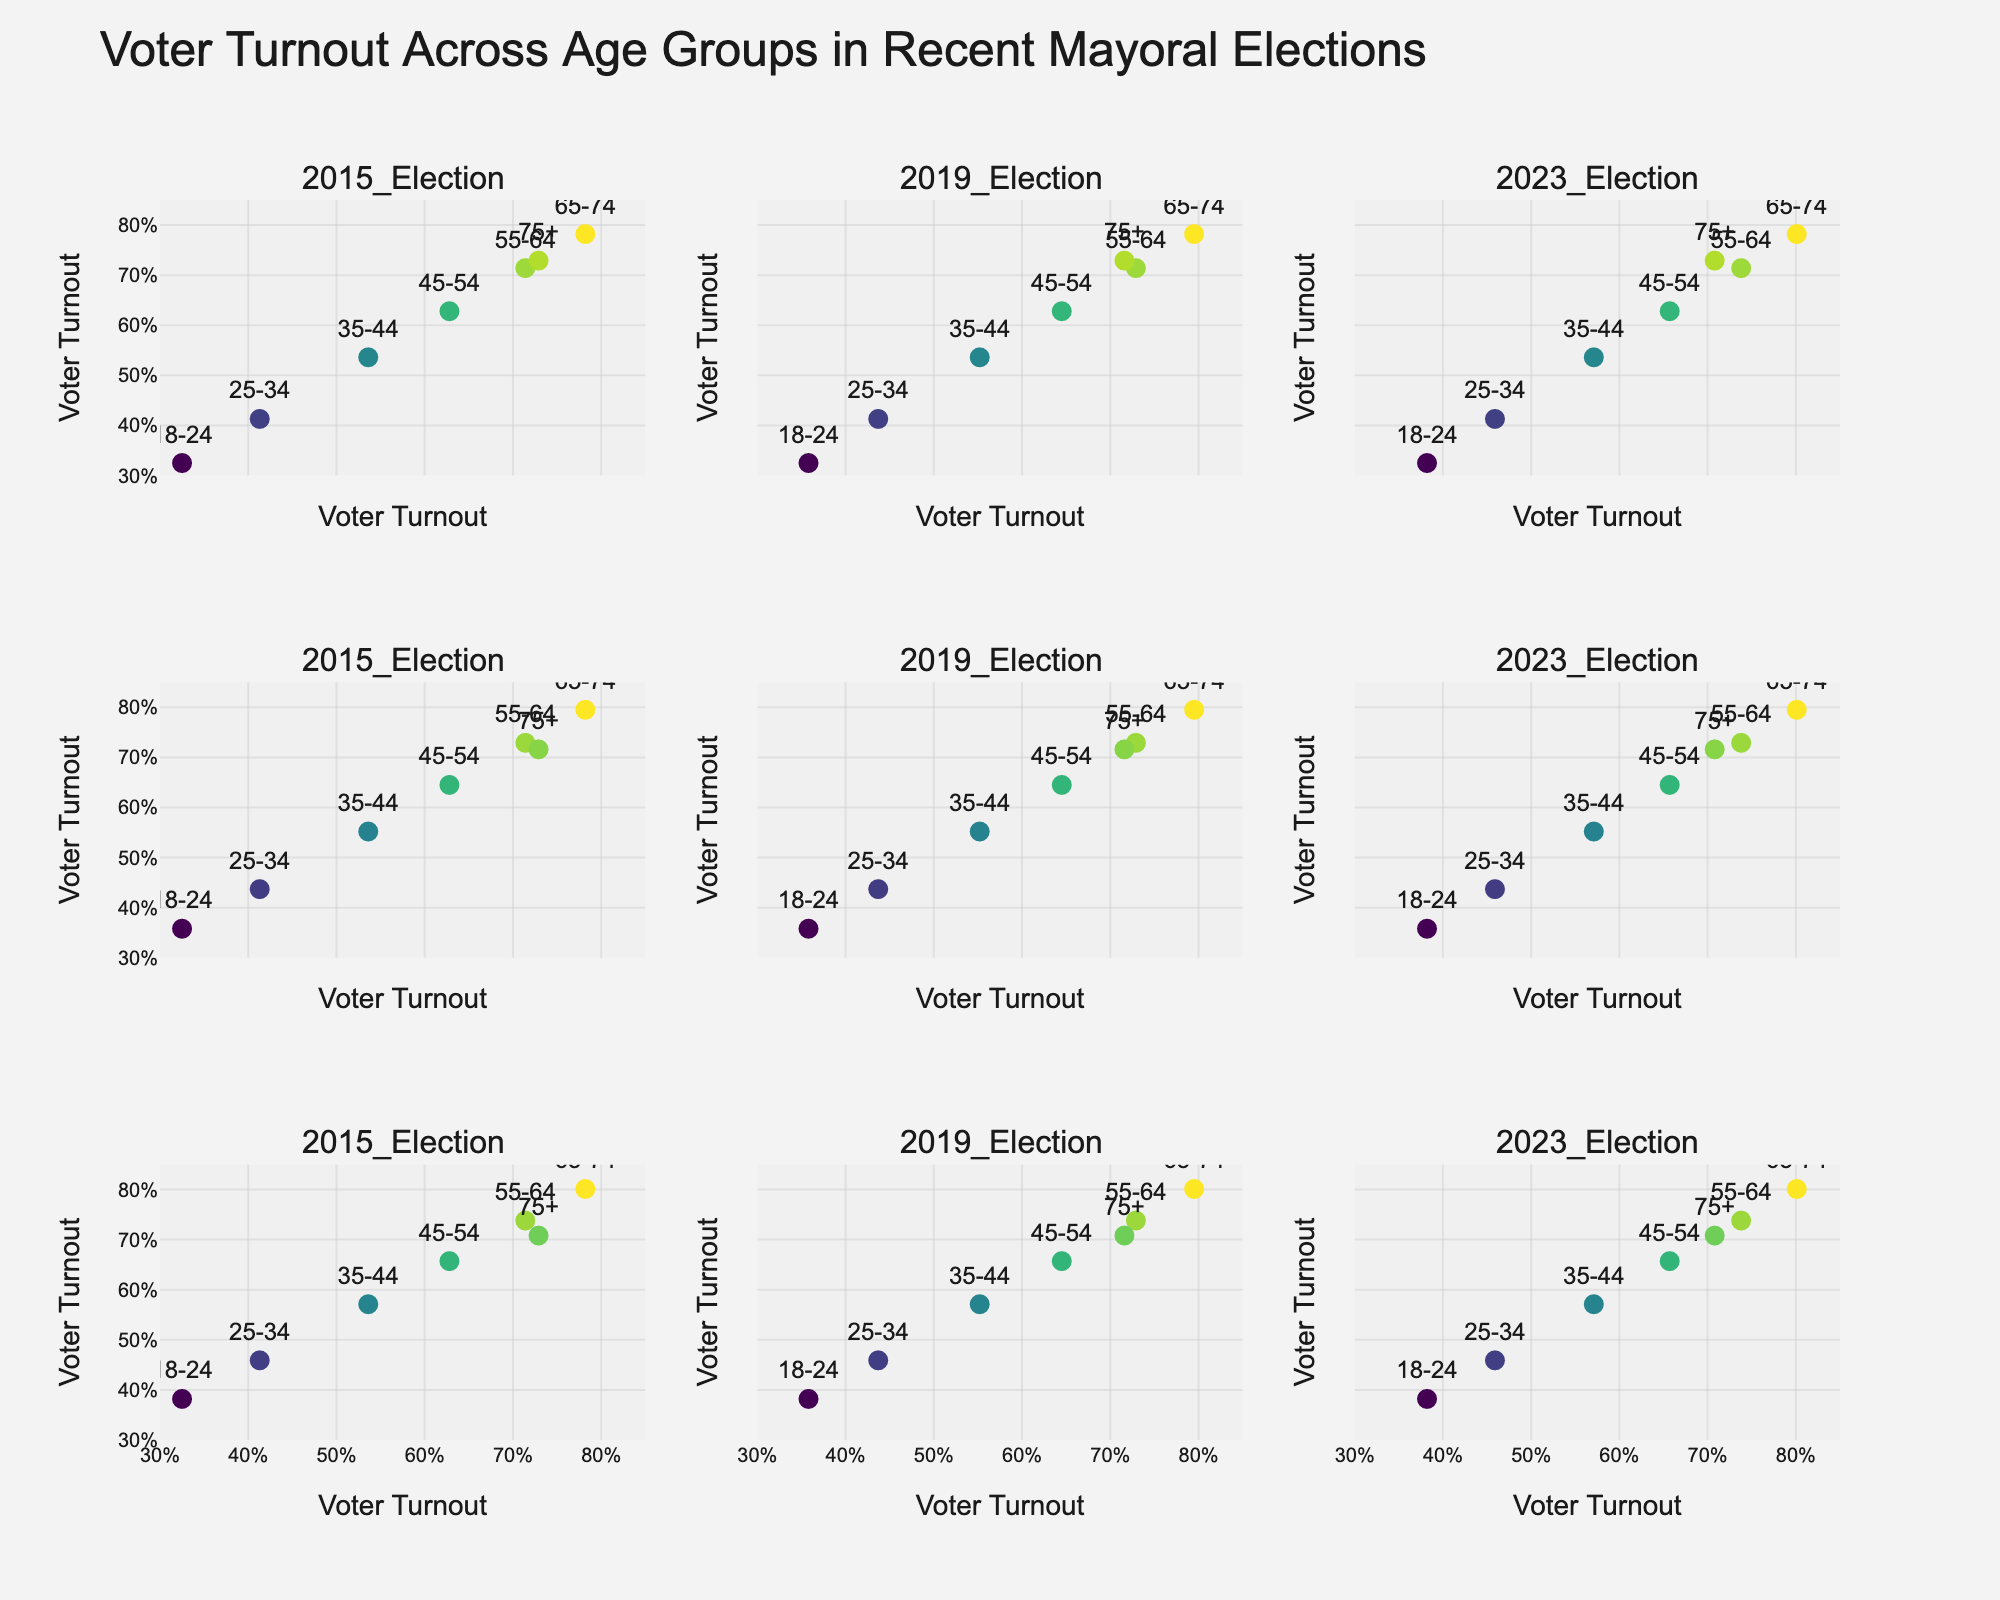What is the title of the plot? The title is usually displayed at the top of the plot. Looking at the provided generated figure, the title "CSR Budget Allocation Across Social Causes by Company Type" is clearly mentioned at the top.
Answer: CSR Budget Allocation Across Social Causes by Company Type Which company type has the highest budget allocation for Education? To answer this, we need to compare the budget allocation percentages for Education across different company types. From the figure, Technology and Retail contribute 20%, while Financial Services and Energy allocate 10%.
Answer: Technology and Retail What social cause has the largest budget allocation from Financial Services companies? Reviewing the figure segment for Financial Services, the highest budget allocation is for Financial Literacy, which is marked by the largest bubble and the percentage value of 30%.
Answer: Financial Literacy Which company type allocated the least budget for Healthcare? Comparing all segments for Healthcare across company types, we find that Technology, Financial Services, Manufacturing, and Energy each allocated 5%, and Retail allocated 0%.
Answer: Retail How many social causes are supported by the Energy sector according to the plot? Count the number of unique social causes listed under the Energy plot section. There are five different causes: Clean Energy Research, Environmental Conservation, Community Development, Education, and Healthcare.
Answer: 5 What is the difference in budget allocation between Vocational Training and Workplace Safety in the Manufacturing sector? According to the figure, Manufacturing allocates 25% to Vocational Training and 20% to Workplace Safety. The difference is calculated as 25% - 20% = 5%.
Answer: 5% Which company type shows the most diversified allocation across all social causes? To determine this, observe the spread of budget allocations across all causes for different companies. Financial Services, allocating 30%, 20%, 15%, 10%, and 5% across its social causes, has the widest diversity in allocation percentages shown by the plot.
Answer: Financial Services 